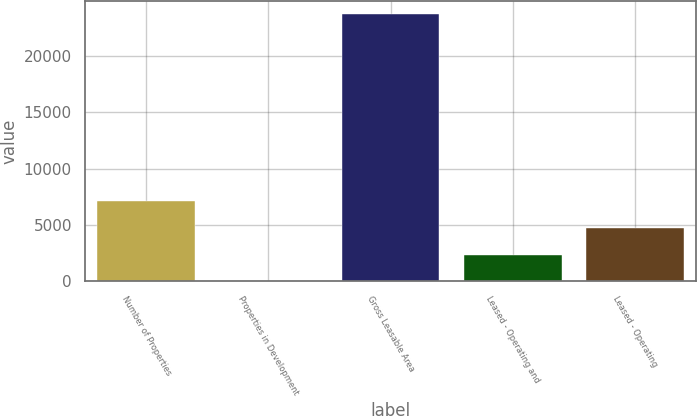Convert chart to OTSL. <chart><loc_0><loc_0><loc_500><loc_500><bar_chart><fcel>Number of Properties<fcel>Properties in Development<fcel>Gross Leasable Area<fcel>Leased - Operating and<fcel>Leased - Operating<nl><fcel>7129.9<fcel>7<fcel>23750<fcel>2381.3<fcel>4755.6<nl></chart> 